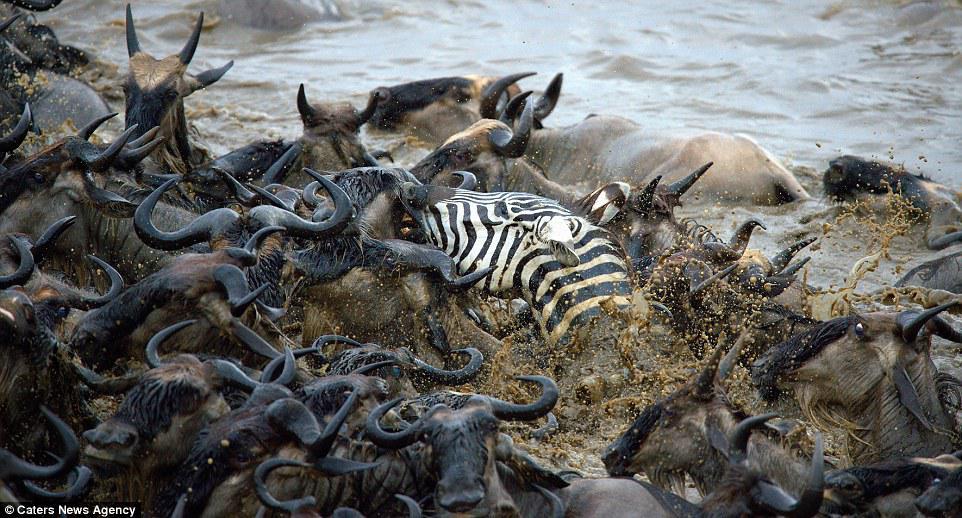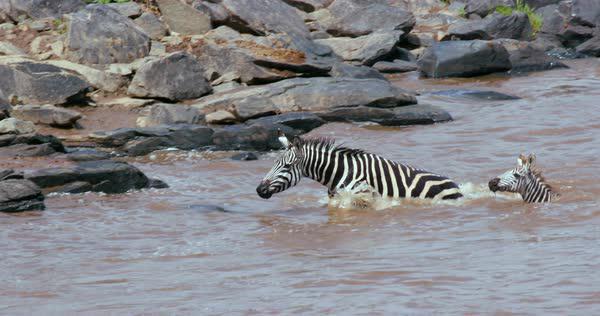The first image is the image on the left, the second image is the image on the right. Considering the images on both sides, is "There are exactly three zebras." valid? Answer yes or no. Yes. The first image is the image on the left, the second image is the image on the right. Considering the images on both sides, is "The right image shows exactly two zebra heading leftward in neck-deep water, one behind the other, and the left image features a zebra with a different type of animal in the water." valid? Answer yes or no. Yes. 